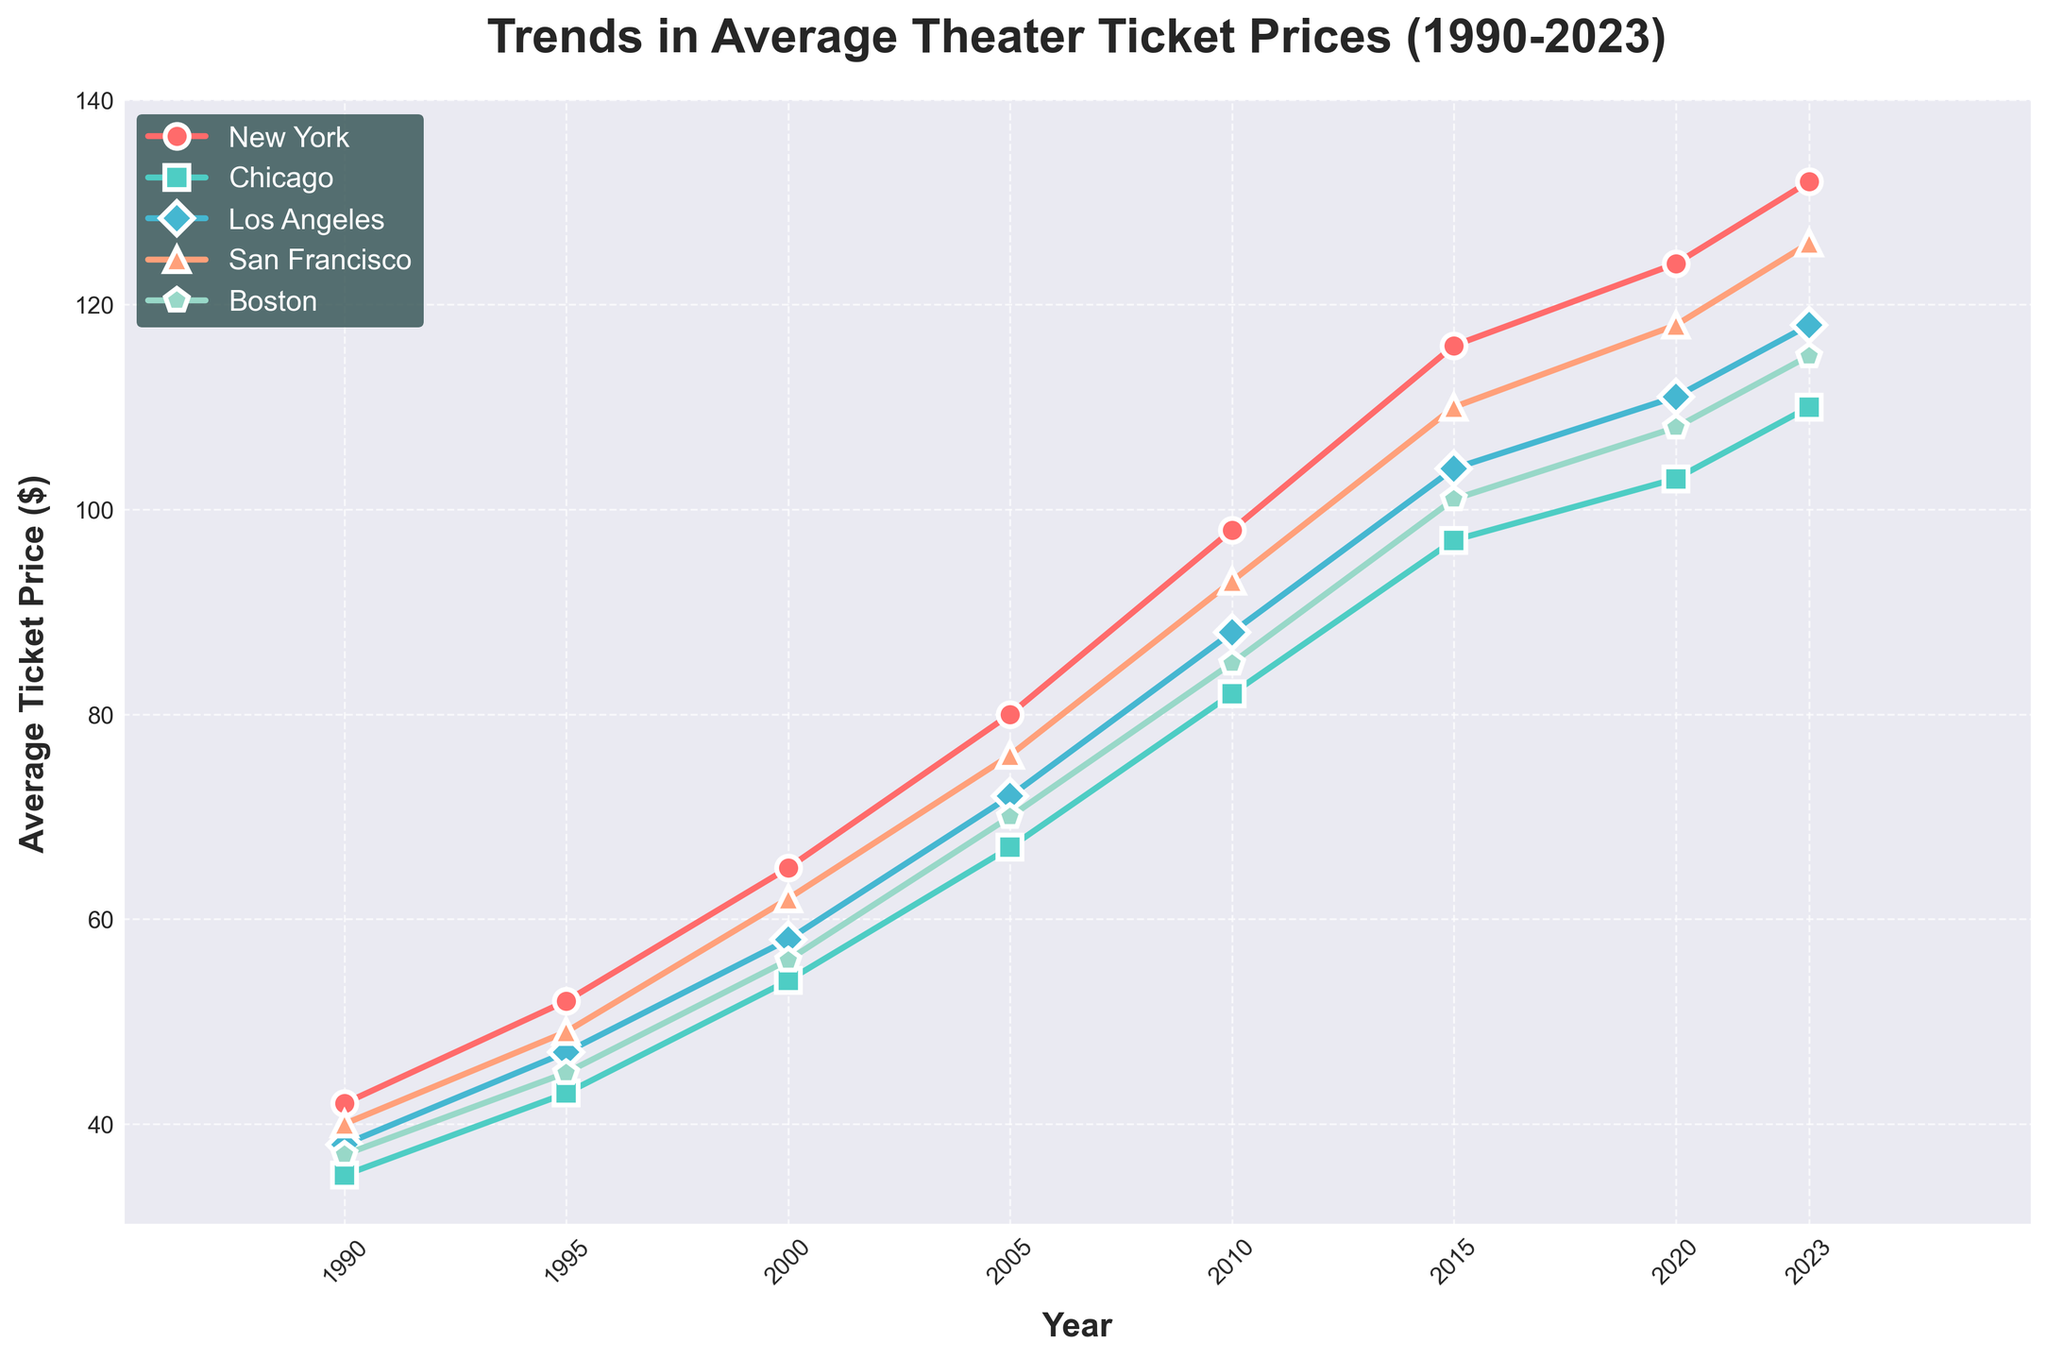What is the general trend in average theater ticket prices from 1990 to 2023? The trend is upward; every city shows a consistent increase in ticket prices over the years from 1990 to 2023, without any noticeable dips or decreases in prices.
Answer: Upward Which city had the highest average ticket price in 2023? By examining the end of each line at the year 2023, the red line (New York) reaches the highest point on the y-axis. Therefore, New York has the highest average ticket price in 2023.
Answer: New York In which year did Los Angeles surpass Boston in terms of average ticket price? Follow the blue (Los Angeles) and green (Boston) lines and note the point where the blue line rises above the green line. This occurs between 2000 and 2005, specifically in the year 2005.
Answer: 2005 What is the difference in average ticket prices between New York and Chicago in 2010? Find the values for New York and Chicago in 2010 (98 and 82, respectively), then compute the difference: 98 - 82.
Answer: 16 Which cities' average ticket prices exceed $100 in 2023? Track the lines in 2023 and note which exceed the $100 mark on the y-axis: New York, San Francisco, and Boston.
Answer: New York, San Francisco, Boston Between which years did San Francisco's average ticket prices increase the most? Observe the segment of the orange (San Francisco) line with the steepest slope. The most significant increase occurs between 2010 and 2015.
Answer: 2010 to 2015 What is the average growth in ticket prices for Boston from 1990 to 2023? Calculate the difference between ticket prices in 2023 and 1990 for Boston (115 - 37 = 78) and divide by the number of years (2023 - 1990 = 33). Average annual growth = 78/33.
Answer: 2.36 (approximately) Which city had the smallest increase in average ticket prices from 1990 to 2023? Calculate the increase for each city and compare: New York (90), Chicago (75), Los Angeles (80), San Francisco (86), Boston (78). Chicago has the smallest increase.
Answer: Chicago What is the ratio of average ticket prices in New York to Chicago in 2023? Divide the average ticket price in New York in 2023 (132) by the price in Chicago (110). Ratio = 132/110.
Answer: 1.2 (approximately) In which year did ticket prices for all cities cross $50? Look for the year when the lowest line on the graph is above $50. The last city to cross it (Chicago) reaches above $50 by 2000.
Answer: 2000 